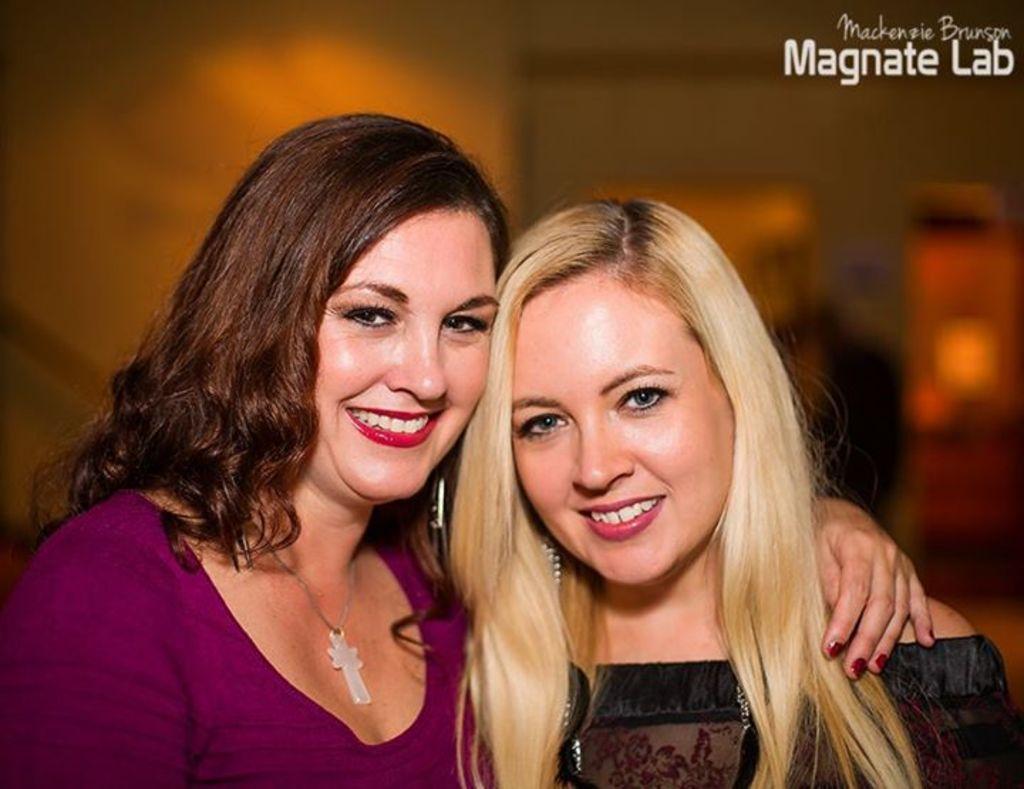How would you summarize this image in a sentence or two? In this picture we can see two women and in the background we can see it is blurry, in the top right we can see some text. 